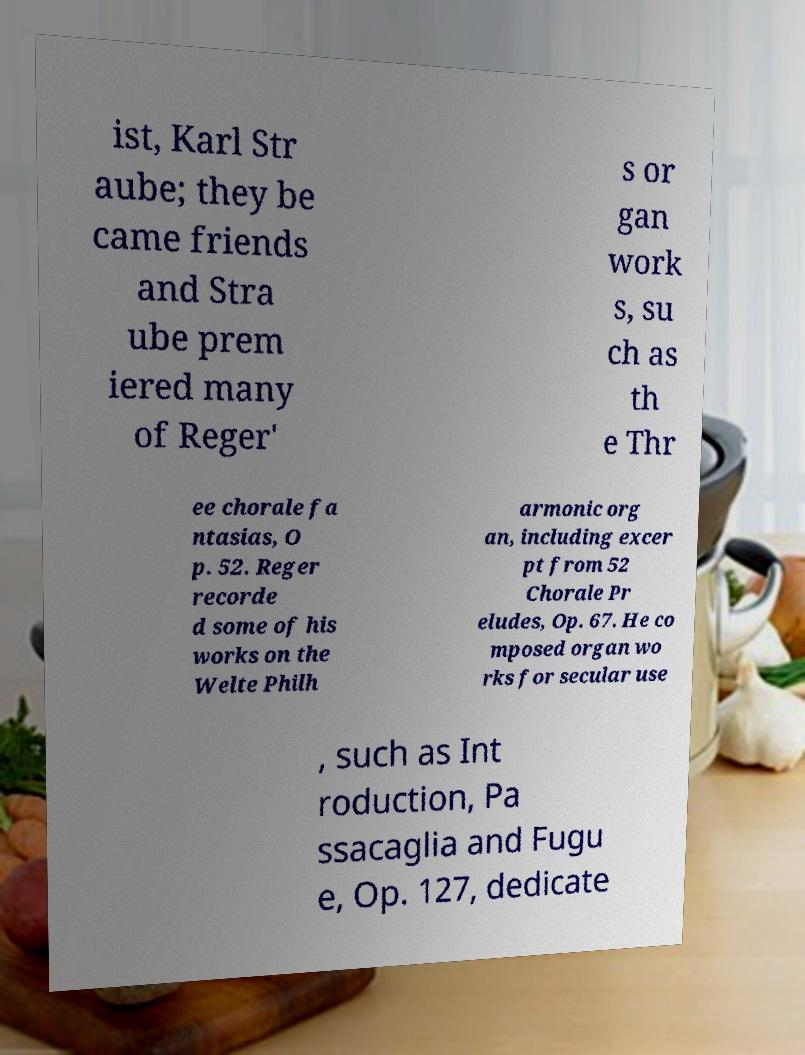Could you assist in decoding the text presented in this image and type it out clearly? ist, Karl Str aube; they be came friends and Stra ube prem iered many of Reger' s or gan work s, su ch as th e Thr ee chorale fa ntasias, O p. 52. Reger recorde d some of his works on the Welte Philh armonic org an, including excer pt from 52 Chorale Pr eludes, Op. 67. He co mposed organ wo rks for secular use , such as Int roduction, Pa ssacaglia and Fugu e, Op. 127, dedicate 